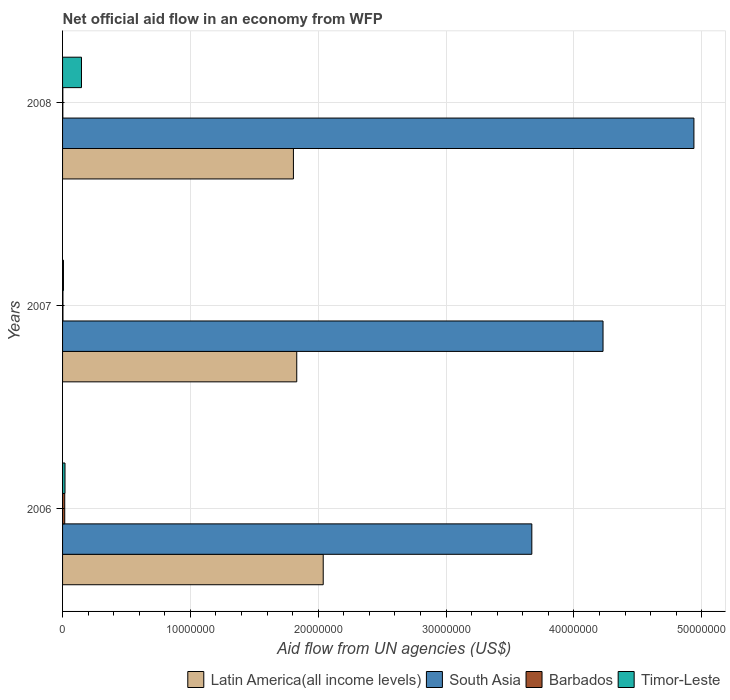How many different coloured bars are there?
Offer a terse response. 4. How many groups of bars are there?
Offer a very short reply. 3. Are the number of bars per tick equal to the number of legend labels?
Provide a succinct answer. Yes. Are the number of bars on each tick of the Y-axis equal?
Provide a succinct answer. Yes. How many bars are there on the 1st tick from the top?
Make the answer very short. 4. How many bars are there on the 1st tick from the bottom?
Give a very brief answer. 4. What is the label of the 3rd group of bars from the top?
Your answer should be compact. 2006. In how many cases, is the number of bars for a given year not equal to the number of legend labels?
Offer a terse response. 0. What is the net official aid flow in Barbados in 2006?
Your response must be concise. 1.70e+05. Across all years, what is the maximum net official aid flow in South Asia?
Provide a short and direct response. 4.94e+07. Across all years, what is the minimum net official aid flow in Timor-Leste?
Ensure brevity in your answer.  7.00e+04. In which year was the net official aid flow in South Asia minimum?
Keep it short and to the point. 2006. What is the total net official aid flow in Barbados in the graph?
Your answer should be very brief. 2.20e+05. What is the difference between the net official aid flow in Latin America(all income levels) in 2006 and that in 2008?
Provide a succinct answer. 2.33e+06. What is the difference between the net official aid flow in South Asia in 2006 and the net official aid flow in Timor-Leste in 2008?
Provide a succinct answer. 3.52e+07. What is the average net official aid flow in Timor-Leste per year?
Offer a terse response. 5.80e+05. In the year 2006, what is the difference between the net official aid flow in Latin America(all income levels) and net official aid flow in Barbados?
Give a very brief answer. 2.02e+07. In how many years, is the net official aid flow in South Asia greater than 24000000 US$?
Provide a short and direct response. 3. What is the ratio of the net official aid flow in Latin America(all income levels) in 2006 to that in 2008?
Ensure brevity in your answer.  1.13. What is the difference between the highest and the second highest net official aid flow in South Asia?
Offer a terse response. 7.11e+06. What is the difference between the highest and the lowest net official aid flow in Barbados?
Provide a short and direct response. 1.50e+05. In how many years, is the net official aid flow in Timor-Leste greater than the average net official aid flow in Timor-Leste taken over all years?
Provide a short and direct response. 1. Is the sum of the net official aid flow in Latin America(all income levels) in 2006 and 2008 greater than the maximum net official aid flow in South Asia across all years?
Provide a succinct answer. No. Is it the case that in every year, the sum of the net official aid flow in Barbados and net official aid flow in Latin America(all income levels) is greater than the sum of net official aid flow in South Asia and net official aid flow in Timor-Leste?
Your answer should be compact. Yes. What does the 1st bar from the top in 2008 represents?
Your answer should be very brief. Timor-Leste. What does the 3rd bar from the bottom in 2006 represents?
Provide a short and direct response. Barbados. Is it the case that in every year, the sum of the net official aid flow in Latin America(all income levels) and net official aid flow in Barbados is greater than the net official aid flow in South Asia?
Your answer should be compact. No. How many bars are there?
Keep it short and to the point. 12. Does the graph contain any zero values?
Your response must be concise. No. Does the graph contain grids?
Make the answer very short. Yes. Where does the legend appear in the graph?
Keep it short and to the point. Bottom right. How many legend labels are there?
Your answer should be compact. 4. How are the legend labels stacked?
Offer a very short reply. Horizontal. What is the title of the graph?
Give a very brief answer. Net official aid flow in an economy from WFP. Does "Afghanistan" appear as one of the legend labels in the graph?
Make the answer very short. No. What is the label or title of the X-axis?
Make the answer very short. Aid flow from UN agencies (US$). What is the label or title of the Y-axis?
Your answer should be very brief. Years. What is the Aid flow from UN agencies (US$) in Latin America(all income levels) in 2006?
Provide a succinct answer. 2.04e+07. What is the Aid flow from UN agencies (US$) in South Asia in 2006?
Keep it short and to the point. 3.67e+07. What is the Aid flow from UN agencies (US$) in Timor-Leste in 2006?
Your answer should be very brief. 1.90e+05. What is the Aid flow from UN agencies (US$) in Latin America(all income levels) in 2007?
Offer a terse response. 1.83e+07. What is the Aid flow from UN agencies (US$) of South Asia in 2007?
Give a very brief answer. 4.23e+07. What is the Aid flow from UN agencies (US$) in Timor-Leste in 2007?
Ensure brevity in your answer.  7.00e+04. What is the Aid flow from UN agencies (US$) of Latin America(all income levels) in 2008?
Offer a very short reply. 1.81e+07. What is the Aid flow from UN agencies (US$) of South Asia in 2008?
Make the answer very short. 4.94e+07. What is the Aid flow from UN agencies (US$) of Timor-Leste in 2008?
Make the answer very short. 1.48e+06. Across all years, what is the maximum Aid flow from UN agencies (US$) of Latin America(all income levels)?
Your answer should be compact. 2.04e+07. Across all years, what is the maximum Aid flow from UN agencies (US$) in South Asia?
Ensure brevity in your answer.  4.94e+07. Across all years, what is the maximum Aid flow from UN agencies (US$) in Timor-Leste?
Your answer should be compact. 1.48e+06. Across all years, what is the minimum Aid flow from UN agencies (US$) in Latin America(all income levels)?
Your answer should be very brief. 1.81e+07. Across all years, what is the minimum Aid flow from UN agencies (US$) in South Asia?
Ensure brevity in your answer.  3.67e+07. Across all years, what is the minimum Aid flow from UN agencies (US$) in Barbados?
Provide a succinct answer. 2.00e+04. What is the total Aid flow from UN agencies (US$) in Latin America(all income levels) in the graph?
Make the answer very short. 5.68e+07. What is the total Aid flow from UN agencies (US$) in South Asia in the graph?
Make the answer very short. 1.28e+08. What is the total Aid flow from UN agencies (US$) in Timor-Leste in the graph?
Your answer should be compact. 1.74e+06. What is the difference between the Aid flow from UN agencies (US$) in Latin America(all income levels) in 2006 and that in 2007?
Keep it short and to the point. 2.07e+06. What is the difference between the Aid flow from UN agencies (US$) in South Asia in 2006 and that in 2007?
Offer a terse response. -5.57e+06. What is the difference between the Aid flow from UN agencies (US$) of Barbados in 2006 and that in 2007?
Your answer should be compact. 1.40e+05. What is the difference between the Aid flow from UN agencies (US$) of Latin America(all income levels) in 2006 and that in 2008?
Offer a very short reply. 2.33e+06. What is the difference between the Aid flow from UN agencies (US$) in South Asia in 2006 and that in 2008?
Provide a short and direct response. -1.27e+07. What is the difference between the Aid flow from UN agencies (US$) of Barbados in 2006 and that in 2008?
Offer a terse response. 1.50e+05. What is the difference between the Aid flow from UN agencies (US$) in Timor-Leste in 2006 and that in 2008?
Keep it short and to the point. -1.29e+06. What is the difference between the Aid flow from UN agencies (US$) of Latin America(all income levels) in 2007 and that in 2008?
Your response must be concise. 2.60e+05. What is the difference between the Aid flow from UN agencies (US$) of South Asia in 2007 and that in 2008?
Provide a short and direct response. -7.11e+06. What is the difference between the Aid flow from UN agencies (US$) in Barbados in 2007 and that in 2008?
Give a very brief answer. 10000. What is the difference between the Aid flow from UN agencies (US$) of Timor-Leste in 2007 and that in 2008?
Offer a terse response. -1.41e+06. What is the difference between the Aid flow from UN agencies (US$) of Latin America(all income levels) in 2006 and the Aid flow from UN agencies (US$) of South Asia in 2007?
Offer a terse response. -2.19e+07. What is the difference between the Aid flow from UN agencies (US$) in Latin America(all income levels) in 2006 and the Aid flow from UN agencies (US$) in Barbados in 2007?
Your answer should be compact. 2.04e+07. What is the difference between the Aid flow from UN agencies (US$) of Latin America(all income levels) in 2006 and the Aid flow from UN agencies (US$) of Timor-Leste in 2007?
Offer a terse response. 2.03e+07. What is the difference between the Aid flow from UN agencies (US$) of South Asia in 2006 and the Aid flow from UN agencies (US$) of Barbados in 2007?
Offer a very short reply. 3.67e+07. What is the difference between the Aid flow from UN agencies (US$) in South Asia in 2006 and the Aid flow from UN agencies (US$) in Timor-Leste in 2007?
Offer a terse response. 3.66e+07. What is the difference between the Aid flow from UN agencies (US$) of Barbados in 2006 and the Aid flow from UN agencies (US$) of Timor-Leste in 2007?
Provide a short and direct response. 1.00e+05. What is the difference between the Aid flow from UN agencies (US$) of Latin America(all income levels) in 2006 and the Aid flow from UN agencies (US$) of South Asia in 2008?
Offer a very short reply. -2.90e+07. What is the difference between the Aid flow from UN agencies (US$) of Latin America(all income levels) in 2006 and the Aid flow from UN agencies (US$) of Barbados in 2008?
Keep it short and to the point. 2.04e+07. What is the difference between the Aid flow from UN agencies (US$) in Latin America(all income levels) in 2006 and the Aid flow from UN agencies (US$) in Timor-Leste in 2008?
Give a very brief answer. 1.89e+07. What is the difference between the Aid flow from UN agencies (US$) in South Asia in 2006 and the Aid flow from UN agencies (US$) in Barbados in 2008?
Keep it short and to the point. 3.67e+07. What is the difference between the Aid flow from UN agencies (US$) of South Asia in 2006 and the Aid flow from UN agencies (US$) of Timor-Leste in 2008?
Offer a terse response. 3.52e+07. What is the difference between the Aid flow from UN agencies (US$) in Barbados in 2006 and the Aid flow from UN agencies (US$) in Timor-Leste in 2008?
Provide a succinct answer. -1.31e+06. What is the difference between the Aid flow from UN agencies (US$) in Latin America(all income levels) in 2007 and the Aid flow from UN agencies (US$) in South Asia in 2008?
Offer a terse response. -3.11e+07. What is the difference between the Aid flow from UN agencies (US$) in Latin America(all income levels) in 2007 and the Aid flow from UN agencies (US$) in Barbados in 2008?
Your answer should be compact. 1.83e+07. What is the difference between the Aid flow from UN agencies (US$) of Latin America(all income levels) in 2007 and the Aid flow from UN agencies (US$) of Timor-Leste in 2008?
Offer a terse response. 1.68e+07. What is the difference between the Aid flow from UN agencies (US$) in South Asia in 2007 and the Aid flow from UN agencies (US$) in Barbados in 2008?
Make the answer very short. 4.23e+07. What is the difference between the Aid flow from UN agencies (US$) in South Asia in 2007 and the Aid flow from UN agencies (US$) in Timor-Leste in 2008?
Offer a very short reply. 4.08e+07. What is the difference between the Aid flow from UN agencies (US$) in Barbados in 2007 and the Aid flow from UN agencies (US$) in Timor-Leste in 2008?
Make the answer very short. -1.45e+06. What is the average Aid flow from UN agencies (US$) in Latin America(all income levels) per year?
Make the answer very short. 1.89e+07. What is the average Aid flow from UN agencies (US$) in South Asia per year?
Ensure brevity in your answer.  4.28e+07. What is the average Aid flow from UN agencies (US$) of Barbados per year?
Make the answer very short. 7.33e+04. What is the average Aid flow from UN agencies (US$) of Timor-Leste per year?
Provide a succinct answer. 5.80e+05. In the year 2006, what is the difference between the Aid flow from UN agencies (US$) in Latin America(all income levels) and Aid flow from UN agencies (US$) in South Asia?
Keep it short and to the point. -1.63e+07. In the year 2006, what is the difference between the Aid flow from UN agencies (US$) of Latin America(all income levels) and Aid flow from UN agencies (US$) of Barbados?
Your response must be concise. 2.02e+07. In the year 2006, what is the difference between the Aid flow from UN agencies (US$) of Latin America(all income levels) and Aid flow from UN agencies (US$) of Timor-Leste?
Provide a succinct answer. 2.02e+07. In the year 2006, what is the difference between the Aid flow from UN agencies (US$) in South Asia and Aid flow from UN agencies (US$) in Barbados?
Keep it short and to the point. 3.65e+07. In the year 2006, what is the difference between the Aid flow from UN agencies (US$) in South Asia and Aid flow from UN agencies (US$) in Timor-Leste?
Your answer should be compact. 3.65e+07. In the year 2007, what is the difference between the Aid flow from UN agencies (US$) in Latin America(all income levels) and Aid flow from UN agencies (US$) in South Asia?
Provide a succinct answer. -2.40e+07. In the year 2007, what is the difference between the Aid flow from UN agencies (US$) of Latin America(all income levels) and Aid flow from UN agencies (US$) of Barbados?
Your answer should be very brief. 1.83e+07. In the year 2007, what is the difference between the Aid flow from UN agencies (US$) in Latin America(all income levels) and Aid flow from UN agencies (US$) in Timor-Leste?
Give a very brief answer. 1.82e+07. In the year 2007, what is the difference between the Aid flow from UN agencies (US$) of South Asia and Aid flow from UN agencies (US$) of Barbados?
Your response must be concise. 4.22e+07. In the year 2007, what is the difference between the Aid flow from UN agencies (US$) of South Asia and Aid flow from UN agencies (US$) of Timor-Leste?
Your response must be concise. 4.22e+07. In the year 2007, what is the difference between the Aid flow from UN agencies (US$) in Barbados and Aid flow from UN agencies (US$) in Timor-Leste?
Offer a very short reply. -4.00e+04. In the year 2008, what is the difference between the Aid flow from UN agencies (US$) in Latin America(all income levels) and Aid flow from UN agencies (US$) in South Asia?
Offer a terse response. -3.13e+07. In the year 2008, what is the difference between the Aid flow from UN agencies (US$) in Latin America(all income levels) and Aid flow from UN agencies (US$) in Barbados?
Ensure brevity in your answer.  1.80e+07. In the year 2008, what is the difference between the Aid flow from UN agencies (US$) of Latin America(all income levels) and Aid flow from UN agencies (US$) of Timor-Leste?
Keep it short and to the point. 1.66e+07. In the year 2008, what is the difference between the Aid flow from UN agencies (US$) of South Asia and Aid flow from UN agencies (US$) of Barbados?
Offer a terse response. 4.94e+07. In the year 2008, what is the difference between the Aid flow from UN agencies (US$) in South Asia and Aid flow from UN agencies (US$) in Timor-Leste?
Keep it short and to the point. 4.79e+07. In the year 2008, what is the difference between the Aid flow from UN agencies (US$) of Barbados and Aid flow from UN agencies (US$) of Timor-Leste?
Your response must be concise. -1.46e+06. What is the ratio of the Aid flow from UN agencies (US$) of Latin America(all income levels) in 2006 to that in 2007?
Your response must be concise. 1.11. What is the ratio of the Aid flow from UN agencies (US$) of South Asia in 2006 to that in 2007?
Keep it short and to the point. 0.87. What is the ratio of the Aid flow from UN agencies (US$) of Barbados in 2006 to that in 2007?
Provide a succinct answer. 5.67. What is the ratio of the Aid flow from UN agencies (US$) of Timor-Leste in 2006 to that in 2007?
Your answer should be compact. 2.71. What is the ratio of the Aid flow from UN agencies (US$) of Latin America(all income levels) in 2006 to that in 2008?
Your answer should be very brief. 1.13. What is the ratio of the Aid flow from UN agencies (US$) in South Asia in 2006 to that in 2008?
Your response must be concise. 0.74. What is the ratio of the Aid flow from UN agencies (US$) in Barbados in 2006 to that in 2008?
Your response must be concise. 8.5. What is the ratio of the Aid flow from UN agencies (US$) of Timor-Leste in 2006 to that in 2008?
Offer a very short reply. 0.13. What is the ratio of the Aid flow from UN agencies (US$) of Latin America(all income levels) in 2007 to that in 2008?
Your answer should be compact. 1.01. What is the ratio of the Aid flow from UN agencies (US$) of South Asia in 2007 to that in 2008?
Make the answer very short. 0.86. What is the ratio of the Aid flow from UN agencies (US$) in Barbados in 2007 to that in 2008?
Provide a short and direct response. 1.5. What is the ratio of the Aid flow from UN agencies (US$) of Timor-Leste in 2007 to that in 2008?
Keep it short and to the point. 0.05. What is the difference between the highest and the second highest Aid flow from UN agencies (US$) of Latin America(all income levels)?
Provide a succinct answer. 2.07e+06. What is the difference between the highest and the second highest Aid flow from UN agencies (US$) of South Asia?
Your answer should be very brief. 7.11e+06. What is the difference between the highest and the second highest Aid flow from UN agencies (US$) in Timor-Leste?
Your response must be concise. 1.29e+06. What is the difference between the highest and the lowest Aid flow from UN agencies (US$) of Latin America(all income levels)?
Your answer should be very brief. 2.33e+06. What is the difference between the highest and the lowest Aid flow from UN agencies (US$) of South Asia?
Keep it short and to the point. 1.27e+07. What is the difference between the highest and the lowest Aid flow from UN agencies (US$) in Timor-Leste?
Offer a very short reply. 1.41e+06. 